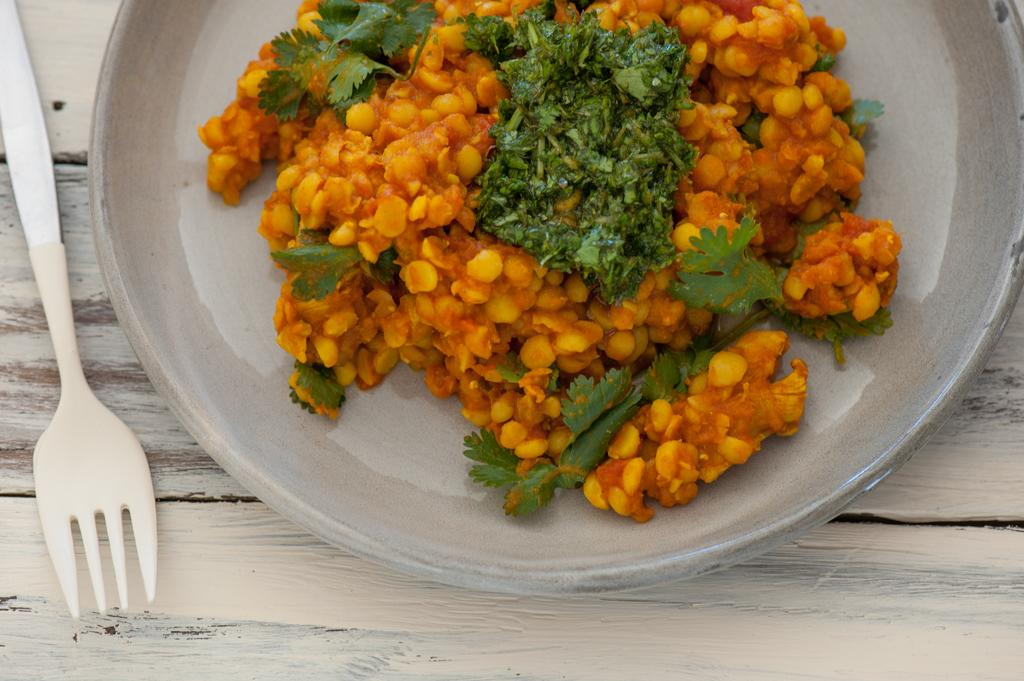What is the main food item visible on a plate in the image? There is a food item on a plate in the image, but the specific type of food cannot be determined from the provided facts. What utensil is present on the table in the image? There is a fork on the table in the image. What type of stem can be seen growing from the food item on the plate? There is no stem visible on the food item in the image, as the specific type of food is not mentioned. Can you describe the cat that is sitting next to the plate in the image? There is no cat present in the image; only a food item on a plate and a fork on the table are visible. 